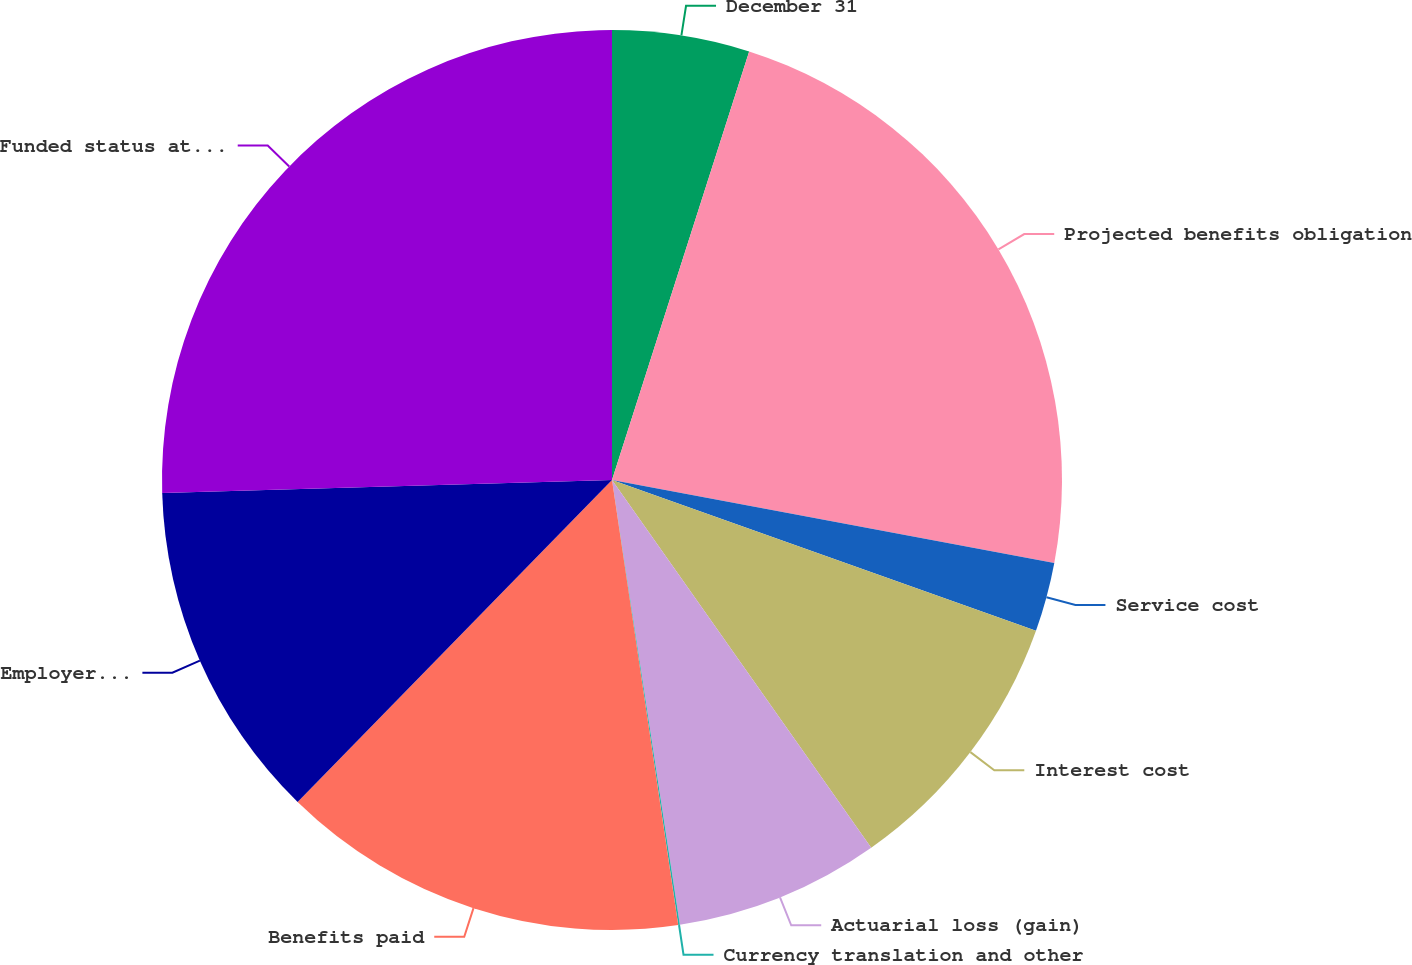<chart> <loc_0><loc_0><loc_500><loc_500><pie_chart><fcel>December 31<fcel>Projected benefits obligation<fcel>Service cost<fcel>Interest cost<fcel>Actuarial loss (gain)<fcel>Currency translation and other<fcel>Benefits paid<fcel>Employer contribution<fcel>Funded status at end of year<nl><fcel>4.93%<fcel>23.02%<fcel>2.49%<fcel>9.79%<fcel>7.36%<fcel>0.06%<fcel>14.66%<fcel>12.23%<fcel>25.46%<nl></chart> 